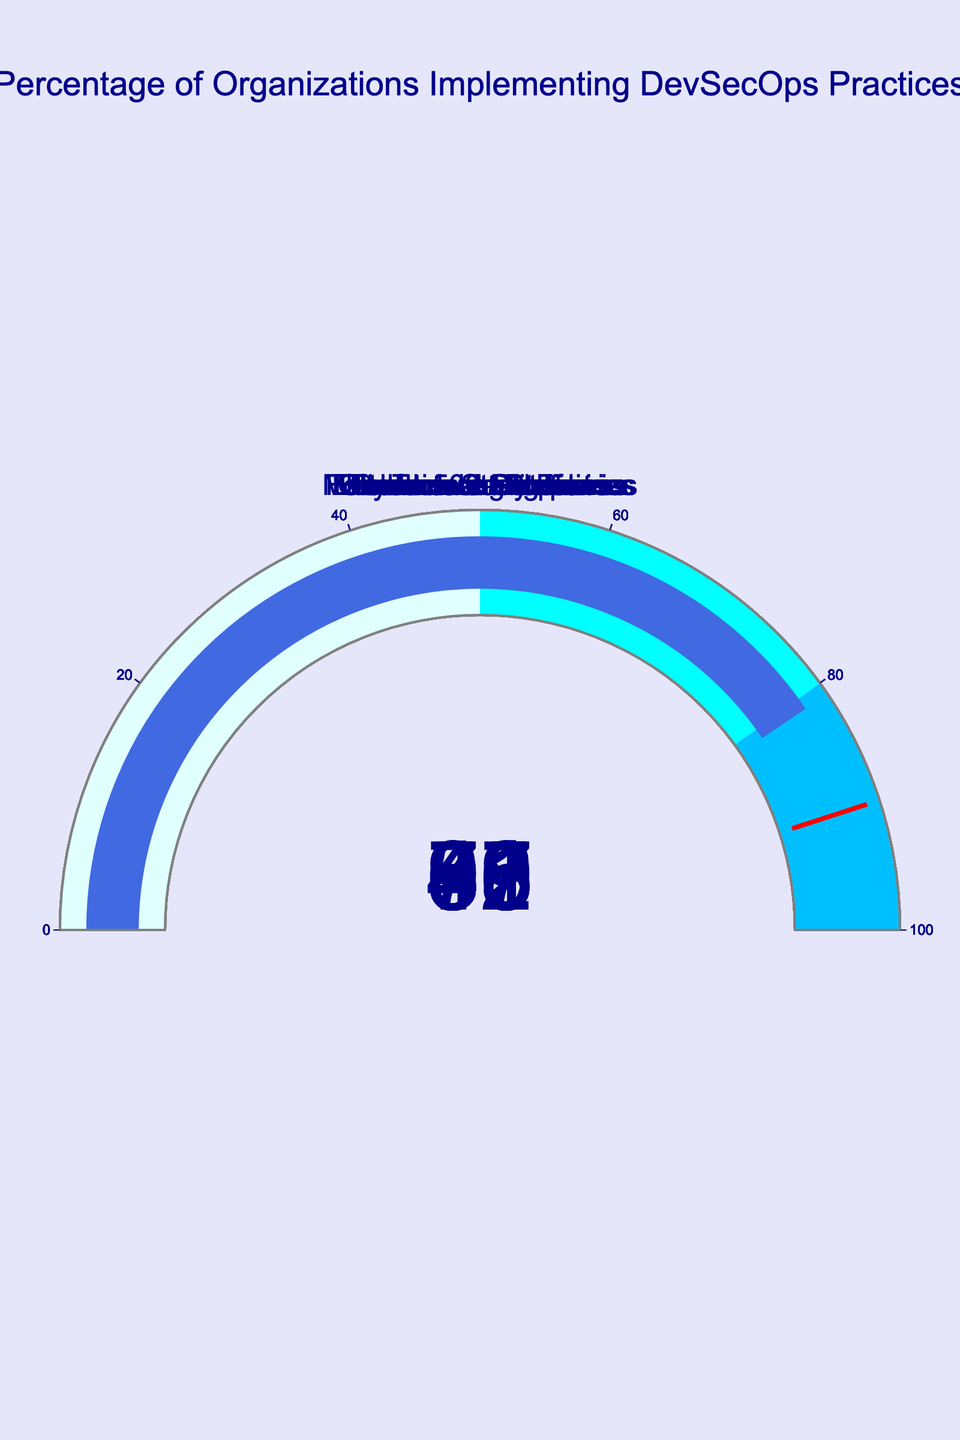What is the title of the figure? The title is displayed at the top center of the figure. It reads "Percentage of Organizations Implementing DevSecOps Practices".
Answer: Percentage of Organizations Implementing DevSecOps Practices How many organizations are represented in the figure? Count the number of gauges presented in the figure. Each gauge represents one organization. There are 10 gauges.
Answer: 10 Which organization has the highest percentage of DevSecOps implementation? Look for the gauge with the highest value on it. Cybersecurity Firms have the highest percentage at 95.
Answer: Cybersecurity Firms What's the range of the gauge axis? The range is displayed on each gauge as part of the visual elements. The axis range is from 0 to 100.
Answer: 0 to 100 How many organizations have a percentage above 80? Identify the gauges with values greater than 80. There are 5 organizations: Tech Startups (92), Financial Institutions (83), E-commerce Platforms (87), Cybersecurity Firms (95), and Telecommunications (81).
Answer: 5 What's the difference in percentage between the organization with the highest and the lowest DevSecOps implementation? Subtract the lowest percentage value from the highest. Cybersecurity Firms have 95%, and Educational Institutions have 39%. The difference is 95 - 39 = 56.
Answer: 56 Which organizations fall within the "deepskyblue" range (80-100%)? Identify the organizations with percentage values in the range 80-100. The organizations are Tech Startups (92), Financial Institutions (83), E-commerce Platforms (87), Cybersecurity Firms (95), and Telecommunications (81).
Answer: Tech Startups, Financial Institutions, E-commerce Platforms, Cybersecurity Firms, Telecommunications What is the average percentage of DevSecOps implementation among all organizations? Add up all the percentages and divide by the number of organizations. (78 + 92 + 45 + 83 + 61 + 39 + 87 + 95 + 56 + 81) / 10 = 71.7
Answer: 71.7 Which organization falls below the threshold value of 90? Identify the organizations with percentage values less than 90. They are Fortune 500 Companies (78), Government Agencies (45), Financial Institutions (83), Healthcare Providers (61), Educational Institutions (39), E-commerce Platforms (87), Manufacturing Industries (56), and Telecommunications (81).
Answer: Fortune 500 Companies, Government Agencies, Financial Institutions, Healthcare Providers, Educational Institutions, E-commerce Platforms, Manufacturing Industries, Telecommunications 